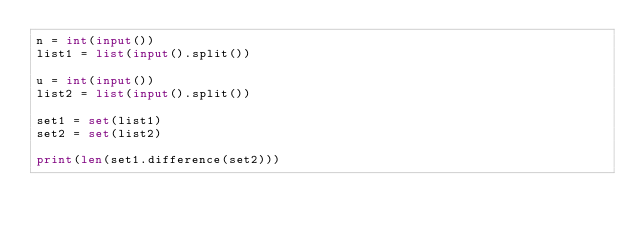Convert code to text. <code><loc_0><loc_0><loc_500><loc_500><_Python_>n = int(input())
list1 = list(input().split())

u = int(input())
list2 = list(input().split())

set1 = set(list1)
set2 = set(list2)

print(len(set1.difference(set2)))</code> 